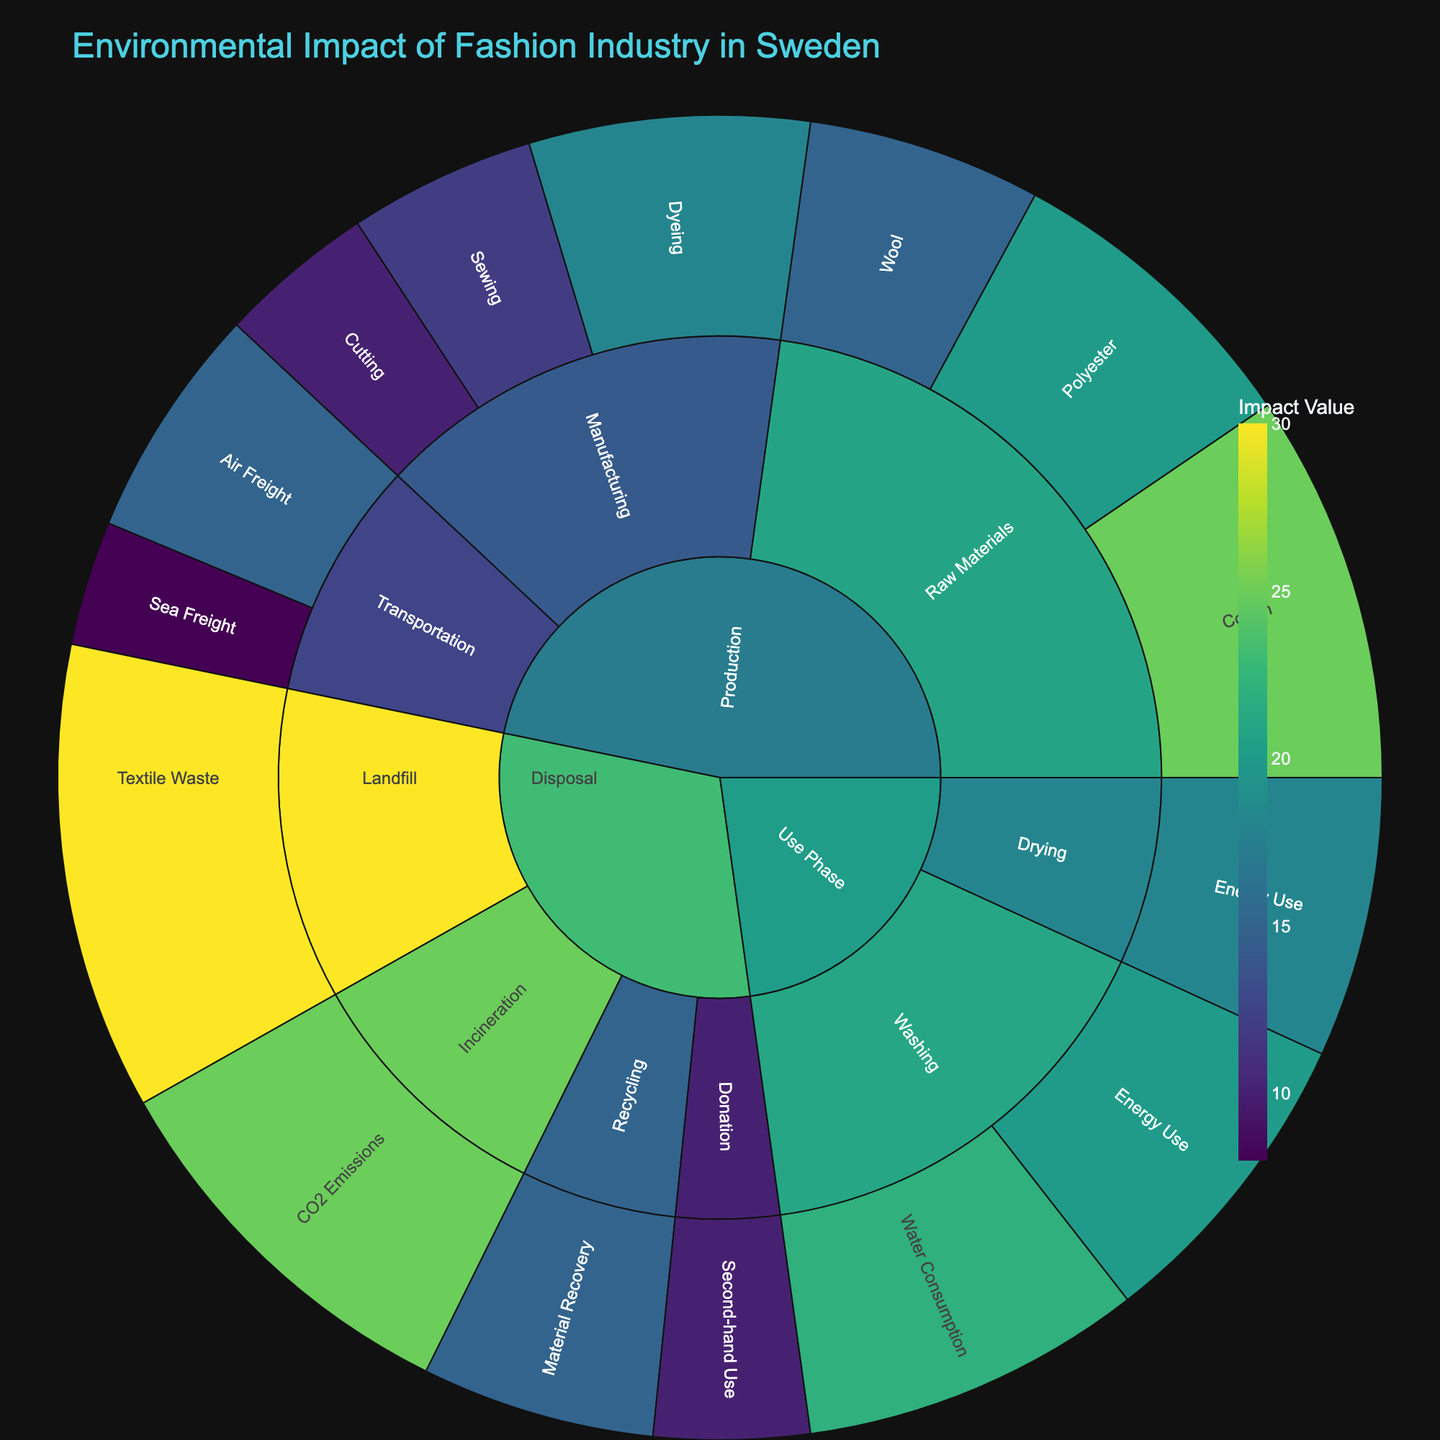How is the environmental impact of fashion divided into different categories and subcategories? The figure shows several primary categories like Production, Use Phase, and Disposal. Each category is further divided into subcategories such as Raw Materials, Manufacturing, and Transportation under Production, and Washing, Drying under Use Phase, and Landfill, Incineration, Recycling, and Donation under Disposal.
Answer: Three main categories: Production, Use Phase, Disposal, with their subcategories Which specific stage or item has the highest environmental impact value in the Disposal category? In the Disposal category, the segment with the highest value is 'Landfill' for 'Textile Waste' with a value of 30, as shown by the size and color intensity of the respective sector.
Answer: Landfill, Textile Waste What's the combined impact value for Raw Materials in the Production category? The Raw Materials subcategory includes Cotton (25), Polyester (20), and Wool (15). Summing these values: 25 + 20 + 15 = 60.
Answer: 60 Which transportation method within the Production category has the least environmental impact? The Production category's Transportation subcategory includes Sea Freight (8) and Air Freight (15). The least impact is from Sea Freight with a value of 8.
Answer: Sea Freight How does the environmental impact value of Washing (Use Phase) compare to Recycling (Disposal)? Washing in the Use Phase has items: Water Consumption (22) and Energy Use (20), giving a combined total of 22 + 20 = 42. Recycling in Disposal has an impact value of 15. Comparing 42 and 15, Washing has a greater impact.
Answer: Washing has a greater impact What are the color differences between Manufacturing and Use Phase categories? In the sunburst plot, colors represent different impact values using a continuous scale. The Manufacturing subcategory has relatively lower values (like Cutting 10, Sewing 12, Dyeing 18) resulting in darker shades, while Use Phase sections (like Washing Water Consumption 22, Energy Use 20) are represented with brighter shades, indicating higher values.
Answer: Manufacturing has darker shades; Use Phase has brighter shades Compare the environmental impact of Polyester and Wool under the Raw Materials subcategory in Production. Polyester has an impact value of 20 while Wool has an impact value of 15 in the Raw Materials subcategory. Polyester's impact is greater.
Answer: Polyester Total environmental impact of the Use Phase category? In the Use Phase category, the impact values are: Washing Water Consumption (22), Energy Use (20), and Drying Energy Use (18). Summing these: 22 + 20 + 18 = 60.
Answer: 60 What is the environmental impact value of Cutting in the Manufacturing subcategory of Production? In the Production category's Manufacturing subcategory, Cutting has an impact value of 10, as indicated by the size and color of the sector.
Answer: 10 Is Landfill more impactful than Use Phase as a whole? The impact value for Landfill is 30. The total Use Phase impact is 60 (22 Washing Water Consumption + 20 Washing Energy Use + 18 Drying). Comparing 30 and 60, Use Phase overall is more impactful.
Answer: Use Phase is more impactful 